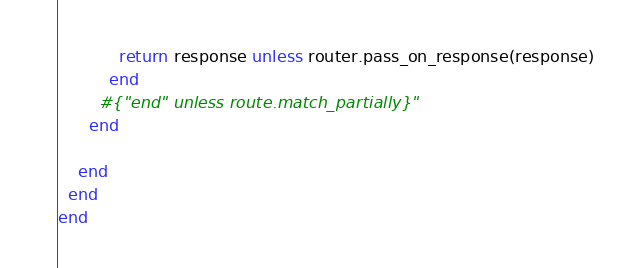Convert code to text. <code><loc_0><loc_0><loc_500><loc_500><_Ruby_>            return response unless router.pass_on_response(response)
          end
        #{"end" unless route.match_partially}"
      end

    end
  end
end
</code> 